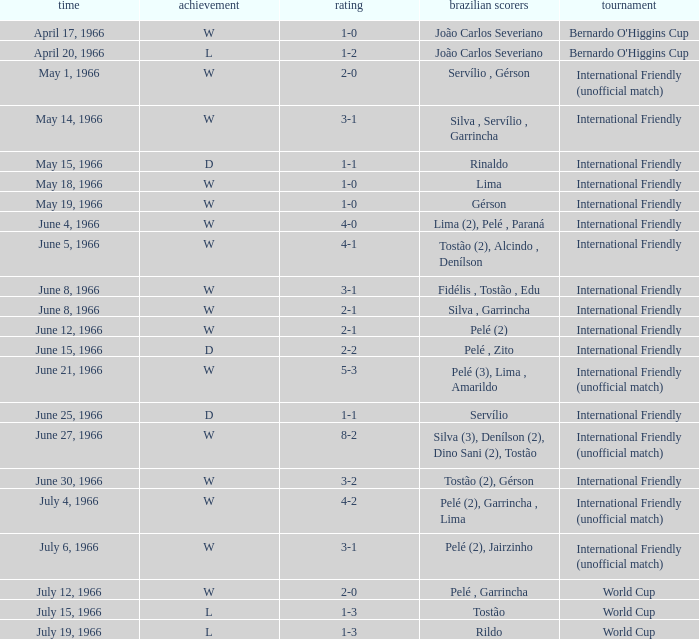What is the result of the International Friendly competition on May 15, 1966? D. 